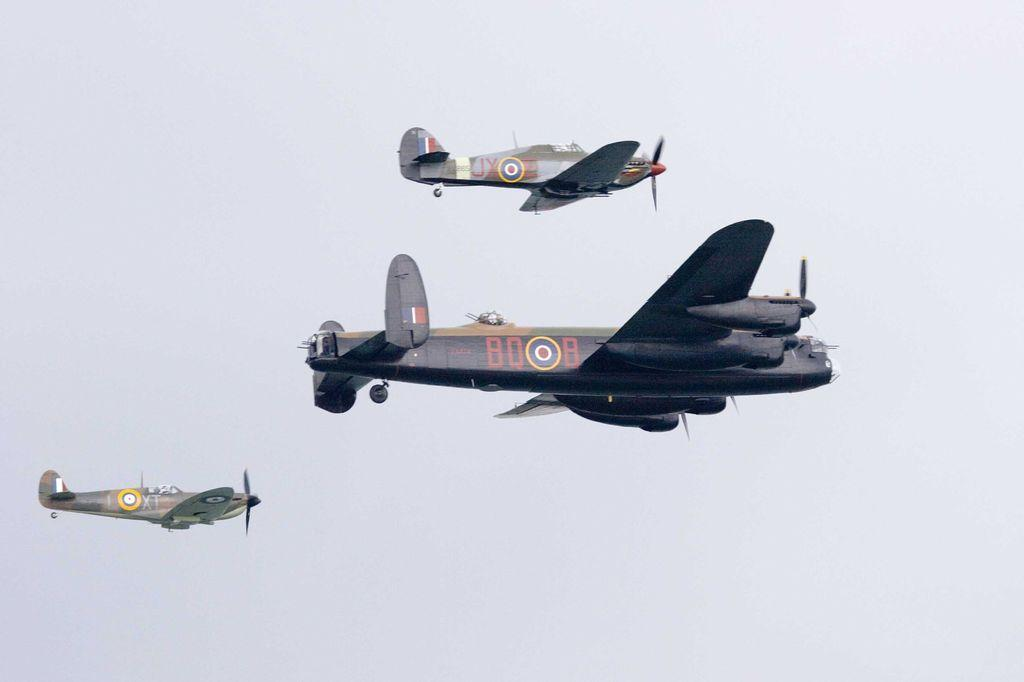Where was the image taken? The image was taken outdoors. What can be seen in the background of the image? There is a sky visible in the background of the image. What is happening in the sky in the image? Three jet airplanes are flying in the sky. What type of riddle is being solved in the lunchroom in the image? There is no lunchroom or riddle present in the image; it features three jet airplanes flying in the sky. Can you describe the rock formation near the jet airplanes in the image? There is no rock formation visible in the image; it only features the sky and the jet airplanes. 